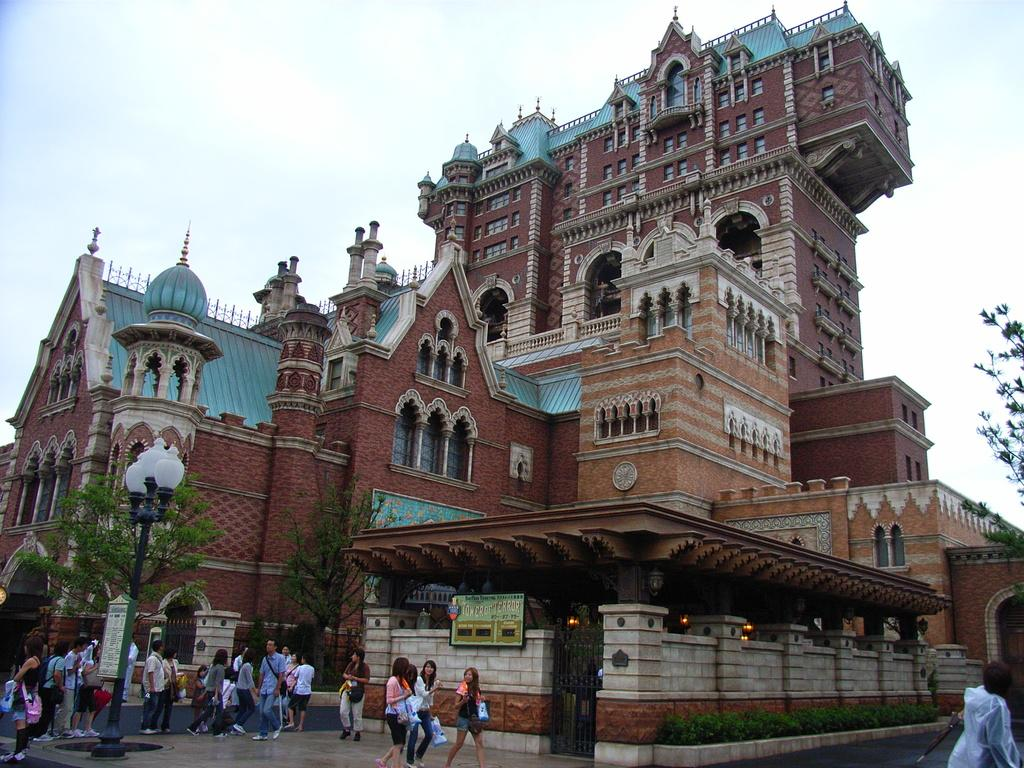What type of structures can be seen in the image? There are buildings in the image. What other natural elements are present in the image? There are trees in the image. What are the people in the image doing? There are people walking in the image. What type of lighting is present in the image? There are lights on poles in the image. What type of signage is present in the image? There are boards with text in the image. How would you describe the weather in the image? The sky is cloudy in the image. Where is the paper located in the image? There is no paper present in the image. What type of farm can be seen on the side of the image? There is no farm present in the image. 